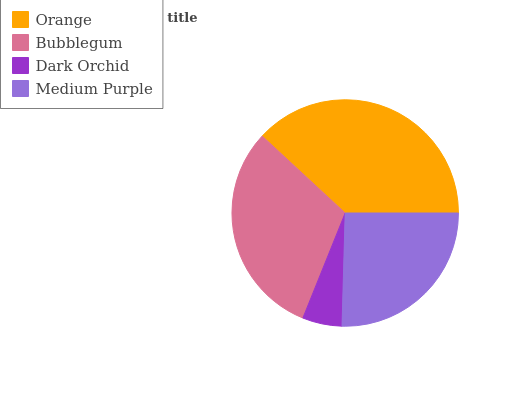Is Dark Orchid the minimum?
Answer yes or no. Yes. Is Orange the maximum?
Answer yes or no. Yes. Is Bubblegum the minimum?
Answer yes or no. No. Is Bubblegum the maximum?
Answer yes or no. No. Is Orange greater than Bubblegum?
Answer yes or no. Yes. Is Bubblegum less than Orange?
Answer yes or no. Yes. Is Bubblegum greater than Orange?
Answer yes or no. No. Is Orange less than Bubblegum?
Answer yes or no. No. Is Bubblegum the high median?
Answer yes or no. Yes. Is Medium Purple the low median?
Answer yes or no. Yes. Is Dark Orchid the high median?
Answer yes or no. No. Is Orange the low median?
Answer yes or no. No. 